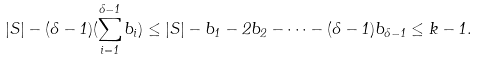Convert formula to latex. <formula><loc_0><loc_0><loc_500><loc_500>| S | - ( \delta - 1 ) ( \sum _ { i = 1 } ^ { \delta - 1 } b _ { i } ) \leq | S | - b _ { 1 } - 2 b _ { 2 } - \cdots - ( \delta - 1 ) b _ { \delta - 1 } \leq k - 1 .</formula> 